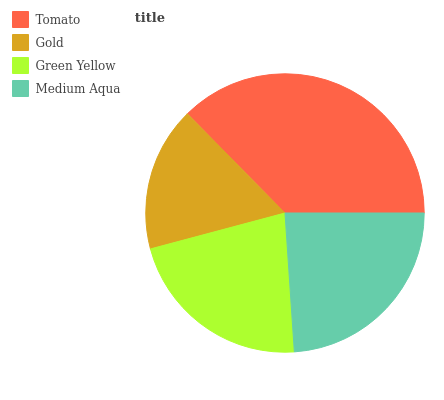Is Gold the minimum?
Answer yes or no. Yes. Is Tomato the maximum?
Answer yes or no. Yes. Is Green Yellow the minimum?
Answer yes or no. No. Is Green Yellow the maximum?
Answer yes or no. No. Is Green Yellow greater than Gold?
Answer yes or no. Yes. Is Gold less than Green Yellow?
Answer yes or no. Yes. Is Gold greater than Green Yellow?
Answer yes or no. No. Is Green Yellow less than Gold?
Answer yes or no. No. Is Medium Aqua the high median?
Answer yes or no. Yes. Is Green Yellow the low median?
Answer yes or no. Yes. Is Tomato the high median?
Answer yes or no. No. Is Tomato the low median?
Answer yes or no. No. 